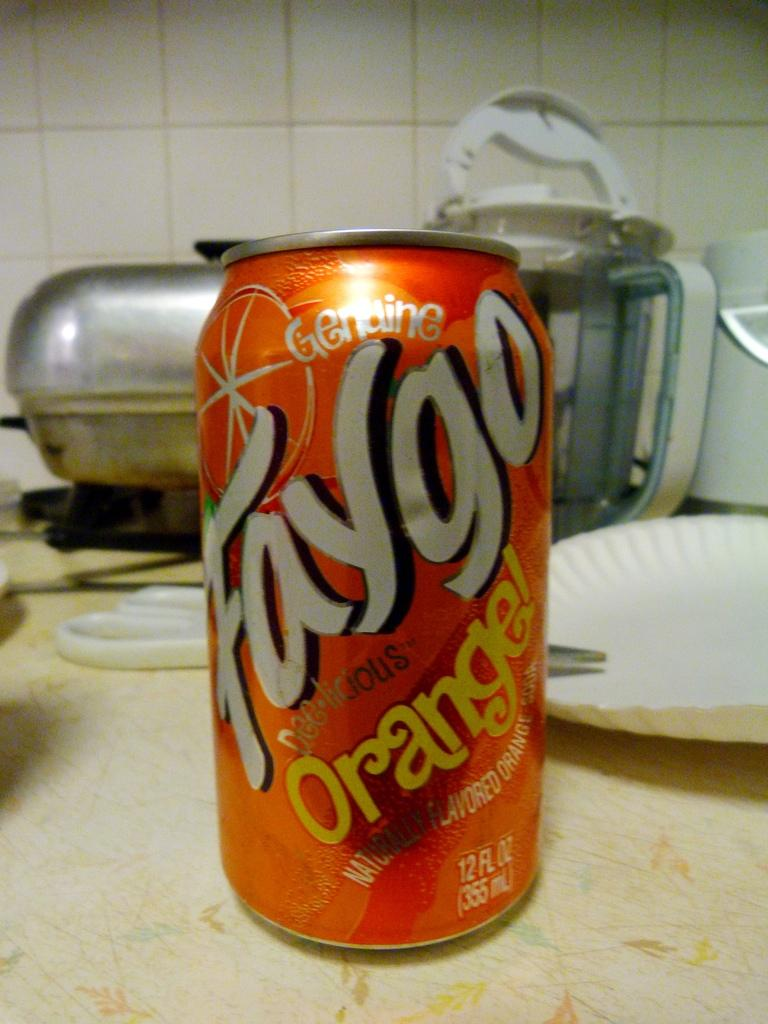Provide a one-sentence caption for the provided image. The very dated counter top has a can of Faygo orange soda sitting on it. 